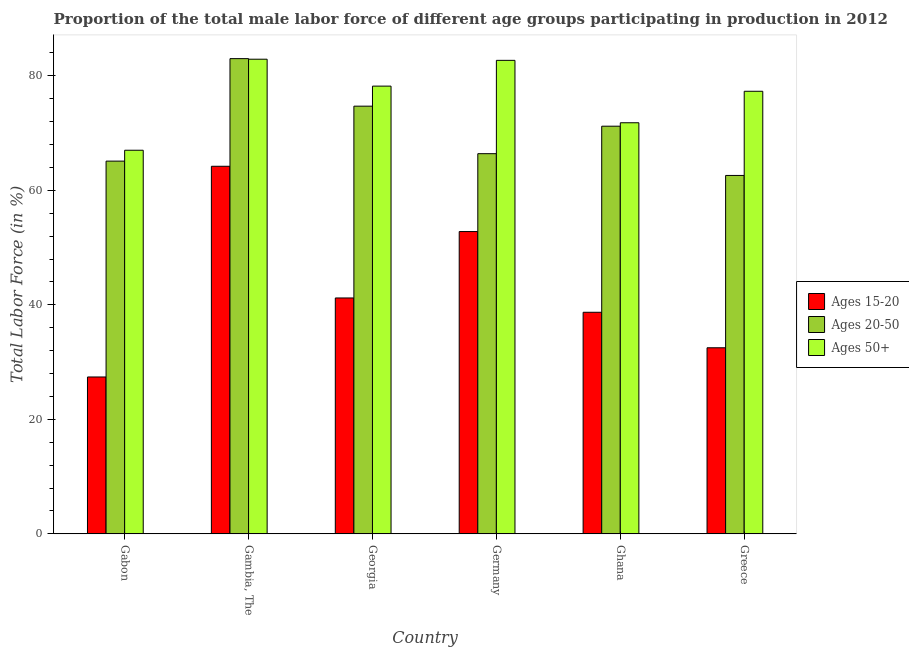How many groups of bars are there?
Your answer should be very brief. 6. Are the number of bars on each tick of the X-axis equal?
Ensure brevity in your answer.  Yes. How many bars are there on the 6th tick from the left?
Your response must be concise. 3. What is the label of the 3rd group of bars from the left?
Offer a terse response. Georgia. What is the percentage of male labor force within the age group 20-50 in Georgia?
Give a very brief answer. 74.7. Across all countries, what is the maximum percentage of male labor force within the age group 15-20?
Your answer should be compact. 64.2. Across all countries, what is the minimum percentage of male labor force within the age group 20-50?
Your answer should be very brief. 62.6. In which country was the percentage of male labor force above age 50 maximum?
Make the answer very short. Gambia, The. In which country was the percentage of male labor force within the age group 20-50 minimum?
Your answer should be compact. Greece. What is the total percentage of male labor force above age 50 in the graph?
Give a very brief answer. 459.9. What is the difference between the percentage of male labor force within the age group 20-50 in Gambia, The and that in Greece?
Make the answer very short. 20.4. What is the difference between the percentage of male labor force within the age group 15-20 in Gabon and the percentage of male labor force within the age group 20-50 in Germany?
Offer a very short reply. -39. What is the average percentage of male labor force within the age group 15-20 per country?
Offer a very short reply. 42.8. What is the difference between the percentage of male labor force within the age group 15-20 and percentage of male labor force above age 50 in Ghana?
Keep it short and to the point. -33.1. What is the ratio of the percentage of male labor force within the age group 15-20 in Gabon to that in Georgia?
Offer a very short reply. 0.67. What is the difference between the highest and the second highest percentage of male labor force above age 50?
Offer a very short reply. 0.2. What is the difference between the highest and the lowest percentage of male labor force above age 50?
Offer a very short reply. 15.9. In how many countries, is the percentage of male labor force within the age group 20-50 greater than the average percentage of male labor force within the age group 20-50 taken over all countries?
Offer a very short reply. 3. What does the 3rd bar from the left in Gabon represents?
Provide a short and direct response. Ages 50+. What does the 2nd bar from the right in Georgia represents?
Give a very brief answer. Ages 20-50. Is it the case that in every country, the sum of the percentage of male labor force within the age group 15-20 and percentage of male labor force within the age group 20-50 is greater than the percentage of male labor force above age 50?
Your answer should be very brief. Yes. How many countries are there in the graph?
Ensure brevity in your answer.  6. What is the difference between two consecutive major ticks on the Y-axis?
Provide a short and direct response. 20. Are the values on the major ticks of Y-axis written in scientific E-notation?
Make the answer very short. No. Does the graph contain any zero values?
Your answer should be compact. No. Does the graph contain grids?
Provide a short and direct response. No. How are the legend labels stacked?
Provide a short and direct response. Vertical. What is the title of the graph?
Make the answer very short. Proportion of the total male labor force of different age groups participating in production in 2012. What is the Total Labor Force (in %) of Ages 15-20 in Gabon?
Your response must be concise. 27.4. What is the Total Labor Force (in %) of Ages 20-50 in Gabon?
Make the answer very short. 65.1. What is the Total Labor Force (in %) in Ages 15-20 in Gambia, The?
Make the answer very short. 64.2. What is the Total Labor Force (in %) of Ages 20-50 in Gambia, The?
Your response must be concise. 83. What is the Total Labor Force (in %) of Ages 50+ in Gambia, The?
Give a very brief answer. 82.9. What is the Total Labor Force (in %) of Ages 15-20 in Georgia?
Keep it short and to the point. 41.2. What is the Total Labor Force (in %) in Ages 20-50 in Georgia?
Your response must be concise. 74.7. What is the Total Labor Force (in %) of Ages 50+ in Georgia?
Give a very brief answer. 78.2. What is the Total Labor Force (in %) of Ages 15-20 in Germany?
Offer a terse response. 52.8. What is the Total Labor Force (in %) in Ages 20-50 in Germany?
Ensure brevity in your answer.  66.4. What is the Total Labor Force (in %) of Ages 50+ in Germany?
Provide a short and direct response. 82.7. What is the Total Labor Force (in %) of Ages 15-20 in Ghana?
Your answer should be very brief. 38.7. What is the Total Labor Force (in %) of Ages 20-50 in Ghana?
Your answer should be compact. 71.2. What is the Total Labor Force (in %) of Ages 50+ in Ghana?
Your response must be concise. 71.8. What is the Total Labor Force (in %) in Ages 15-20 in Greece?
Offer a terse response. 32.5. What is the Total Labor Force (in %) in Ages 20-50 in Greece?
Give a very brief answer. 62.6. What is the Total Labor Force (in %) in Ages 50+ in Greece?
Keep it short and to the point. 77.3. Across all countries, what is the maximum Total Labor Force (in %) of Ages 15-20?
Your answer should be very brief. 64.2. Across all countries, what is the maximum Total Labor Force (in %) of Ages 20-50?
Ensure brevity in your answer.  83. Across all countries, what is the maximum Total Labor Force (in %) in Ages 50+?
Your response must be concise. 82.9. Across all countries, what is the minimum Total Labor Force (in %) in Ages 15-20?
Keep it short and to the point. 27.4. Across all countries, what is the minimum Total Labor Force (in %) of Ages 20-50?
Keep it short and to the point. 62.6. What is the total Total Labor Force (in %) of Ages 15-20 in the graph?
Provide a short and direct response. 256.8. What is the total Total Labor Force (in %) in Ages 20-50 in the graph?
Give a very brief answer. 423. What is the total Total Labor Force (in %) of Ages 50+ in the graph?
Offer a terse response. 459.9. What is the difference between the Total Labor Force (in %) of Ages 15-20 in Gabon and that in Gambia, The?
Make the answer very short. -36.8. What is the difference between the Total Labor Force (in %) of Ages 20-50 in Gabon and that in Gambia, The?
Make the answer very short. -17.9. What is the difference between the Total Labor Force (in %) in Ages 50+ in Gabon and that in Gambia, The?
Provide a succinct answer. -15.9. What is the difference between the Total Labor Force (in %) in Ages 15-20 in Gabon and that in Georgia?
Your response must be concise. -13.8. What is the difference between the Total Labor Force (in %) in Ages 50+ in Gabon and that in Georgia?
Make the answer very short. -11.2. What is the difference between the Total Labor Force (in %) in Ages 15-20 in Gabon and that in Germany?
Provide a short and direct response. -25.4. What is the difference between the Total Labor Force (in %) in Ages 50+ in Gabon and that in Germany?
Provide a short and direct response. -15.7. What is the difference between the Total Labor Force (in %) of Ages 20-50 in Gambia, The and that in Georgia?
Provide a succinct answer. 8.3. What is the difference between the Total Labor Force (in %) of Ages 15-20 in Gambia, The and that in Germany?
Your response must be concise. 11.4. What is the difference between the Total Labor Force (in %) of Ages 50+ in Gambia, The and that in Germany?
Offer a very short reply. 0.2. What is the difference between the Total Labor Force (in %) in Ages 20-50 in Gambia, The and that in Ghana?
Provide a short and direct response. 11.8. What is the difference between the Total Labor Force (in %) of Ages 15-20 in Gambia, The and that in Greece?
Provide a short and direct response. 31.7. What is the difference between the Total Labor Force (in %) of Ages 20-50 in Gambia, The and that in Greece?
Your answer should be very brief. 20.4. What is the difference between the Total Labor Force (in %) of Ages 50+ in Gambia, The and that in Greece?
Make the answer very short. 5.6. What is the difference between the Total Labor Force (in %) of Ages 20-50 in Georgia and that in Germany?
Keep it short and to the point. 8.3. What is the difference between the Total Labor Force (in %) of Ages 20-50 in Georgia and that in Ghana?
Your response must be concise. 3.5. What is the difference between the Total Labor Force (in %) of Ages 50+ in Georgia and that in Ghana?
Offer a terse response. 6.4. What is the difference between the Total Labor Force (in %) of Ages 15-20 in Georgia and that in Greece?
Give a very brief answer. 8.7. What is the difference between the Total Labor Force (in %) in Ages 50+ in Georgia and that in Greece?
Your response must be concise. 0.9. What is the difference between the Total Labor Force (in %) of Ages 15-20 in Germany and that in Ghana?
Keep it short and to the point. 14.1. What is the difference between the Total Labor Force (in %) of Ages 50+ in Germany and that in Ghana?
Your response must be concise. 10.9. What is the difference between the Total Labor Force (in %) of Ages 15-20 in Germany and that in Greece?
Your answer should be compact. 20.3. What is the difference between the Total Labor Force (in %) of Ages 15-20 in Ghana and that in Greece?
Offer a very short reply. 6.2. What is the difference between the Total Labor Force (in %) of Ages 15-20 in Gabon and the Total Labor Force (in %) of Ages 20-50 in Gambia, The?
Offer a very short reply. -55.6. What is the difference between the Total Labor Force (in %) in Ages 15-20 in Gabon and the Total Labor Force (in %) in Ages 50+ in Gambia, The?
Provide a short and direct response. -55.5. What is the difference between the Total Labor Force (in %) in Ages 20-50 in Gabon and the Total Labor Force (in %) in Ages 50+ in Gambia, The?
Offer a very short reply. -17.8. What is the difference between the Total Labor Force (in %) of Ages 15-20 in Gabon and the Total Labor Force (in %) of Ages 20-50 in Georgia?
Keep it short and to the point. -47.3. What is the difference between the Total Labor Force (in %) in Ages 15-20 in Gabon and the Total Labor Force (in %) in Ages 50+ in Georgia?
Provide a short and direct response. -50.8. What is the difference between the Total Labor Force (in %) in Ages 20-50 in Gabon and the Total Labor Force (in %) in Ages 50+ in Georgia?
Offer a very short reply. -13.1. What is the difference between the Total Labor Force (in %) of Ages 15-20 in Gabon and the Total Labor Force (in %) of Ages 20-50 in Germany?
Your response must be concise. -39. What is the difference between the Total Labor Force (in %) of Ages 15-20 in Gabon and the Total Labor Force (in %) of Ages 50+ in Germany?
Provide a short and direct response. -55.3. What is the difference between the Total Labor Force (in %) in Ages 20-50 in Gabon and the Total Labor Force (in %) in Ages 50+ in Germany?
Make the answer very short. -17.6. What is the difference between the Total Labor Force (in %) in Ages 15-20 in Gabon and the Total Labor Force (in %) in Ages 20-50 in Ghana?
Offer a very short reply. -43.8. What is the difference between the Total Labor Force (in %) of Ages 15-20 in Gabon and the Total Labor Force (in %) of Ages 50+ in Ghana?
Offer a terse response. -44.4. What is the difference between the Total Labor Force (in %) in Ages 15-20 in Gabon and the Total Labor Force (in %) in Ages 20-50 in Greece?
Provide a short and direct response. -35.2. What is the difference between the Total Labor Force (in %) of Ages 15-20 in Gabon and the Total Labor Force (in %) of Ages 50+ in Greece?
Offer a terse response. -49.9. What is the difference between the Total Labor Force (in %) of Ages 20-50 in Gabon and the Total Labor Force (in %) of Ages 50+ in Greece?
Your answer should be very brief. -12.2. What is the difference between the Total Labor Force (in %) of Ages 15-20 in Gambia, The and the Total Labor Force (in %) of Ages 50+ in Georgia?
Provide a short and direct response. -14. What is the difference between the Total Labor Force (in %) of Ages 20-50 in Gambia, The and the Total Labor Force (in %) of Ages 50+ in Georgia?
Give a very brief answer. 4.8. What is the difference between the Total Labor Force (in %) in Ages 15-20 in Gambia, The and the Total Labor Force (in %) in Ages 50+ in Germany?
Make the answer very short. -18.5. What is the difference between the Total Labor Force (in %) of Ages 15-20 in Gambia, The and the Total Labor Force (in %) of Ages 50+ in Ghana?
Your answer should be very brief. -7.6. What is the difference between the Total Labor Force (in %) in Ages 15-20 in Gambia, The and the Total Labor Force (in %) in Ages 20-50 in Greece?
Your answer should be compact. 1.6. What is the difference between the Total Labor Force (in %) of Ages 15-20 in Gambia, The and the Total Labor Force (in %) of Ages 50+ in Greece?
Keep it short and to the point. -13.1. What is the difference between the Total Labor Force (in %) of Ages 20-50 in Gambia, The and the Total Labor Force (in %) of Ages 50+ in Greece?
Give a very brief answer. 5.7. What is the difference between the Total Labor Force (in %) in Ages 15-20 in Georgia and the Total Labor Force (in %) in Ages 20-50 in Germany?
Ensure brevity in your answer.  -25.2. What is the difference between the Total Labor Force (in %) of Ages 15-20 in Georgia and the Total Labor Force (in %) of Ages 50+ in Germany?
Keep it short and to the point. -41.5. What is the difference between the Total Labor Force (in %) in Ages 20-50 in Georgia and the Total Labor Force (in %) in Ages 50+ in Germany?
Your response must be concise. -8. What is the difference between the Total Labor Force (in %) of Ages 15-20 in Georgia and the Total Labor Force (in %) of Ages 50+ in Ghana?
Your response must be concise. -30.6. What is the difference between the Total Labor Force (in %) in Ages 20-50 in Georgia and the Total Labor Force (in %) in Ages 50+ in Ghana?
Ensure brevity in your answer.  2.9. What is the difference between the Total Labor Force (in %) of Ages 15-20 in Georgia and the Total Labor Force (in %) of Ages 20-50 in Greece?
Provide a short and direct response. -21.4. What is the difference between the Total Labor Force (in %) of Ages 15-20 in Georgia and the Total Labor Force (in %) of Ages 50+ in Greece?
Provide a short and direct response. -36.1. What is the difference between the Total Labor Force (in %) of Ages 15-20 in Germany and the Total Labor Force (in %) of Ages 20-50 in Ghana?
Keep it short and to the point. -18.4. What is the difference between the Total Labor Force (in %) of Ages 15-20 in Germany and the Total Labor Force (in %) of Ages 50+ in Ghana?
Offer a very short reply. -19. What is the difference between the Total Labor Force (in %) of Ages 20-50 in Germany and the Total Labor Force (in %) of Ages 50+ in Ghana?
Your answer should be very brief. -5.4. What is the difference between the Total Labor Force (in %) of Ages 15-20 in Germany and the Total Labor Force (in %) of Ages 50+ in Greece?
Offer a very short reply. -24.5. What is the difference between the Total Labor Force (in %) of Ages 15-20 in Ghana and the Total Labor Force (in %) of Ages 20-50 in Greece?
Make the answer very short. -23.9. What is the difference between the Total Labor Force (in %) of Ages 15-20 in Ghana and the Total Labor Force (in %) of Ages 50+ in Greece?
Provide a succinct answer. -38.6. What is the average Total Labor Force (in %) in Ages 15-20 per country?
Your answer should be very brief. 42.8. What is the average Total Labor Force (in %) of Ages 20-50 per country?
Offer a terse response. 70.5. What is the average Total Labor Force (in %) of Ages 50+ per country?
Provide a short and direct response. 76.65. What is the difference between the Total Labor Force (in %) in Ages 15-20 and Total Labor Force (in %) in Ages 20-50 in Gabon?
Provide a succinct answer. -37.7. What is the difference between the Total Labor Force (in %) of Ages 15-20 and Total Labor Force (in %) of Ages 50+ in Gabon?
Your answer should be compact. -39.6. What is the difference between the Total Labor Force (in %) in Ages 20-50 and Total Labor Force (in %) in Ages 50+ in Gabon?
Give a very brief answer. -1.9. What is the difference between the Total Labor Force (in %) of Ages 15-20 and Total Labor Force (in %) of Ages 20-50 in Gambia, The?
Offer a very short reply. -18.8. What is the difference between the Total Labor Force (in %) of Ages 15-20 and Total Labor Force (in %) of Ages 50+ in Gambia, The?
Provide a succinct answer. -18.7. What is the difference between the Total Labor Force (in %) in Ages 20-50 and Total Labor Force (in %) in Ages 50+ in Gambia, The?
Provide a succinct answer. 0.1. What is the difference between the Total Labor Force (in %) of Ages 15-20 and Total Labor Force (in %) of Ages 20-50 in Georgia?
Offer a very short reply. -33.5. What is the difference between the Total Labor Force (in %) of Ages 15-20 and Total Labor Force (in %) of Ages 50+ in Georgia?
Offer a terse response. -37. What is the difference between the Total Labor Force (in %) in Ages 15-20 and Total Labor Force (in %) in Ages 20-50 in Germany?
Give a very brief answer. -13.6. What is the difference between the Total Labor Force (in %) in Ages 15-20 and Total Labor Force (in %) in Ages 50+ in Germany?
Offer a terse response. -29.9. What is the difference between the Total Labor Force (in %) of Ages 20-50 and Total Labor Force (in %) of Ages 50+ in Germany?
Keep it short and to the point. -16.3. What is the difference between the Total Labor Force (in %) in Ages 15-20 and Total Labor Force (in %) in Ages 20-50 in Ghana?
Give a very brief answer. -32.5. What is the difference between the Total Labor Force (in %) in Ages 15-20 and Total Labor Force (in %) in Ages 50+ in Ghana?
Your answer should be compact. -33.1. What is the difference between the Total Labor Force (in %) of Ages 20-50 and Total Labor Force (in %) of Ages 50+ in Ghana?
Offer a terse response. -0.6. What is the difference between the Total Labor Force (in %) of Ages 15-20 and Total Labor Force (in %) of Ages 20-50 in Greece?
Ensure brevity in your answer.  -30.1. What is the difference between the Total Labor Force (in %) in Ages 15-20 and Total Labor Force (in %) in Ages 50+ in Greece?
Your answer should be compact. -44.8. What is the difference between the Total Labor Force (in %) of Ages 20-50 and Total Labor Force (in %) of Ages 50+ in Greece?
Make the answer very short. -14.7. What is the ratio of the Total Labor Force (in %) of Ages 15-20 in Gabon to that in Gambia, The?
Provide a succinct answer. 0.43. What is the ratio of the Total Labor Force (in %) in Ages 20-50 in Gabon to that in Gambia, The?
Keep it short and to the point. 0.78. What is the ratio of the Total Labor Force (in %) in Ages 50+ in Gabon to that in Gambia, The?
Your answer should be compact. 0.81. What is the ratio of the Total Labor Force (in %) of Ages 15-20 in Gabon to that in Georgia?
Ensure brevity in your answer.  0.67. What is the ratio of the Total Labor Force (in %) of Ages 20-50 in Gabon to that in Georgia?
Give a very brief answer. 0.87. What is the ratio of the Total Labor Force (in %) of Ages 50+ in Gabon to that in Georgia?
Provide a short and direct response. 0.86. What is the ratio of the Total Labor Force (in %) of Ages 15-20 in Gabon to that in Germany?
Offer a terse response. 0.52. What is the ratio of the Total Labor Force (in %) of Ages 20-50 in Gabon to that in Germany?
Keep it short and to the point. 0.98. What is the ratio of the Total Labor Force (in %) of Ages 50+ in Gabon to that in Germany?
Make the answer very short. 0.81. What is the ratio of the Total Labor Force (in %) of Ages 15-20 in Gabon to that in Ghana?
Your answer should be compact. 0.71. What is the ratio of the Total Labor Force (in %) of Ages 20-50 in Gabon to that in Ghana?
Make the answer very short. 0.91. What is the ratio of the Total Labor Force (in %) of Ages 50+ in Gabon to that in Ghana?
Ensure brevity in your answer.  0.93. What is the ratio of the Total Labor Force (in %) in Ages 15-20 in Gabon to that in Greece?
Make the answer very short. 0.84. What is the ratio of the Total Labor Force (in %) in Ages 20-50 in Gabon to that in Greece?
Your answer should be very brief. 1.04. What is the ratio of the Total Labor Force (in %) of Ages 50+ in Gabon to that in Greece?
Your answer should be very brief. 0.87. What is the ratio of the Total Labor Force (in %) in Ages 15-20 in Gambia, The to that in Georgia?
Ensure brevity in your answer.  1.56. What is the ratio of the Total Labor Force (in %) of Ages 50+ in Gambia, The to that in Georgia?
Your answer should be very brief. 1.06. What is the ratio of the Total Labor Force (in %) of Ages 15-20 in Gambia, The to that in Germany?
Offer a very short reply. 1.22. What is the ratio of the Total Labor Force (in %) of Ages 20-50 in Gambia, The to that in Germany?
Offer a terse response. 1.25. What is the ratio of the Total Labor Force (in %) in Ages 15-20 in Gambia, The to that in Ghana?
Offer a terse response. 1.66. What is the ratio of the Total Labor Force (in %) in Ages 20-50 in Gambia, The to that in Ghana?
Offer a terse response. 1.17. What is the ratio of the Total Labor Force (in %) of Ages 50+ in Gambia, The to that in Ghana?
Offer a terse response. 1.15. What is the ratio of the Total Labor Force (in %) of Ages 15-20 in Gambia, The to that in Greece?
Keep it short and to the point. 1.98. What is the ratio of the Total Labor Force (in %) of Ages 20-50 in Gambia, The to that in Greece?
Your answer should be compact. 1.33. What is the ratio of the Total Labor Force (in %) in Ages 50+ in Gambia, The to that in Greece?
Make the answer very short. 1.07. What is the ratio of the Total Labor Force (in %) of Ages 15-20 in Georgia to that in Germany?
Your answer should be very brief. 0.78. What is the ratio of the Total Labor Force (in %) in Ages 50+ in Georgia to that in Germany?
Offer a terse response. 0.95. What is the ratio of the Total Labor Force (in %) in Ages 15-20 in Georgia to that in Ghana?
Offer a terse response. 1.06. What is the ratio of the Total Labor Force (in %) in Ages 20-50 in Georgia to that in Ghana?
Provide a succinct answer. 1.05. What is the ratio of the Total Labor Force (in %) of Ages 50+ in Georgia to that in Ghana?
Ensure brevity in your answer.  1.09. What is the ratio of the Total Labor Force (in %) of Ages 15-20 in Georgia to that in Greece?
Ensure brevity in your answer.  1.27. What is the ratio of the Total Labor Force (in %) of Ages 20-50 in Georgia to that in Greece?
Offer a terse response. 1.19. What is the ratio of the Total Labor Force (in %) in Ages 50+ in Georgia to that in Greece?
Make the answer very short. 1.01. What is the ratio of the Total Labor Force (in %) in Ages 15-20 in Germany to that in Ghana?
Your answer should be very brief. 1.36. What is the ratio of the Total Labor Force (in %) of Ages 20-50 in Germany to that in Ghana?
Provide a short and direct response. 0.93. What is the ratio of the Total Labor Force (in %) of Ages 50+ in Germany to that in Ghana?
Provide a short and direct response. 1.15. What is the ratio of the Total Labor Force (in %) in Ages 15-20 in Germany to that in Greece?
Provide a succinct answer. 1.62. What is the ratio of the Total Labor Force (in %) in Ages 20-50 in Germany to that in Greece?
Provide a succinct answer. 1.06. What is the ratio of the Total Labor Force (in %) in Ages 50+ in Germany to that in Greece?
Provide a succinct answer. 1.07. What is the ratio of the Total Labor Force (in %) in Ages 15-20 in Ghana to that in Greece?
Give a very brief answer. 1.19. What is the ratio of the Total Labor Force (in %) of Ages 20-50 in Ghana to that in Greece?
Ensure brevity in your answer.  1.14. What is the ratio of the Total Labor Force (in %) in Ages 50+ in Ghana to that in Greece?
Offer a very short reply. 0.93. What is the difference between the highest and the lowest Total Labor Force (in %) of Ages 15-20?
Offer a very short reply. 36.8. What is the difference between the highest and the lowest Total Labor Force (in %) of Ages 20-50?
Provide a succinct answer. 20.4. What is the difference between the highest and the lowest Total Labor Force (in %) of Ages 50+?
Provide a succinct answer. 15.9. 